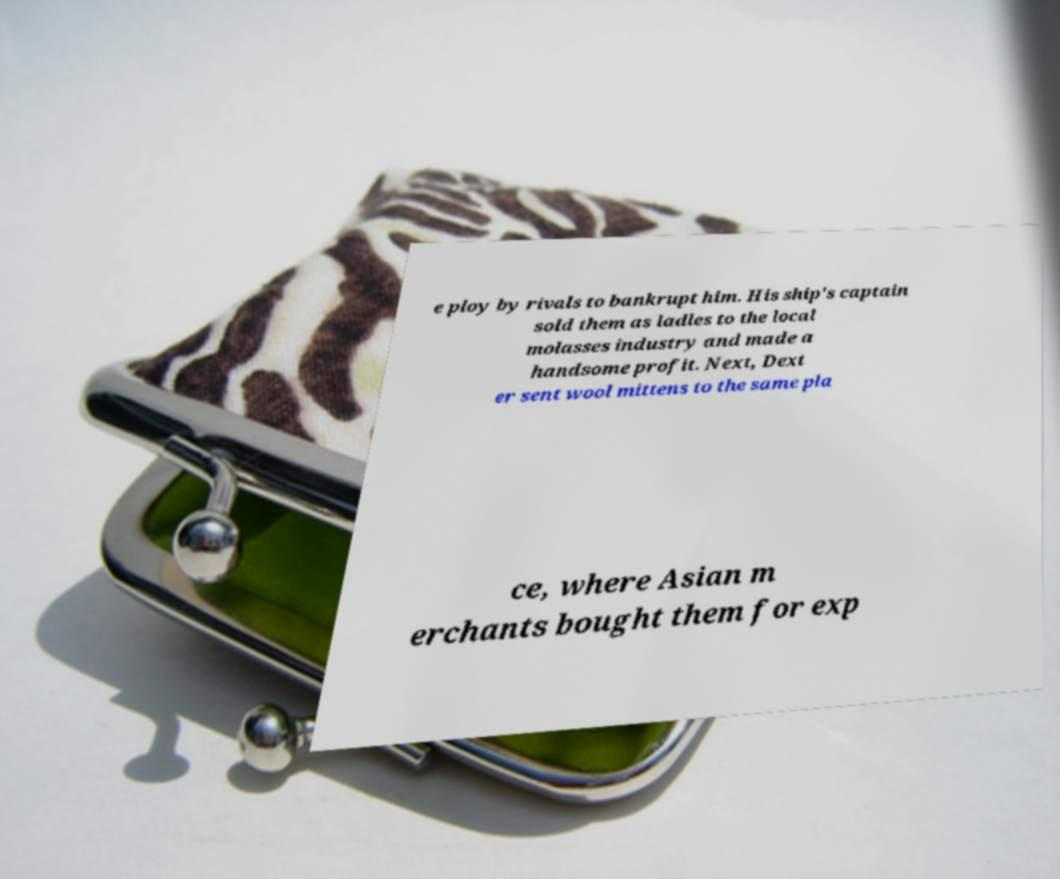I need the written content from this picture converted into text. Can you do that? e ploy by rivals to bankrupt him. His ship's captain sold them as ladles to the local molasses industry and made a handsome profit. Next, Dext er sent wool mittens to the same pla ce, where Asian m erchants bought them for exp 